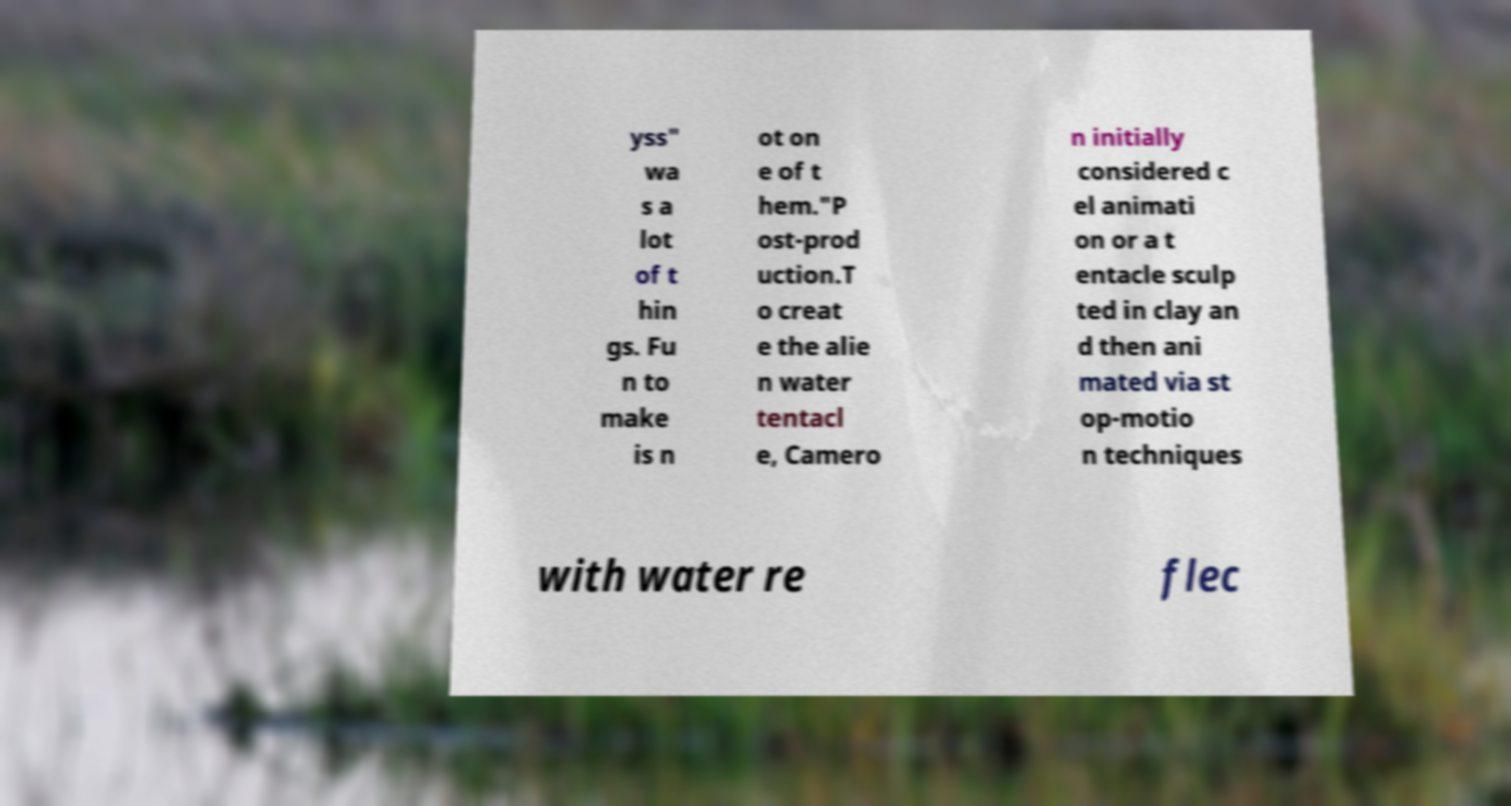I need the written content from this picture converted into text. Can you do that? yss" wa s a lot of t hin gs. Fu n to make is n ot on e of t hem."P ost-prod uction.T o creat e the alie n water tentacl e, Camero n initially considered c el animati on or a t entacle sculp ted in clay an d then ani mated via st op-motio n techniques with water re flec 